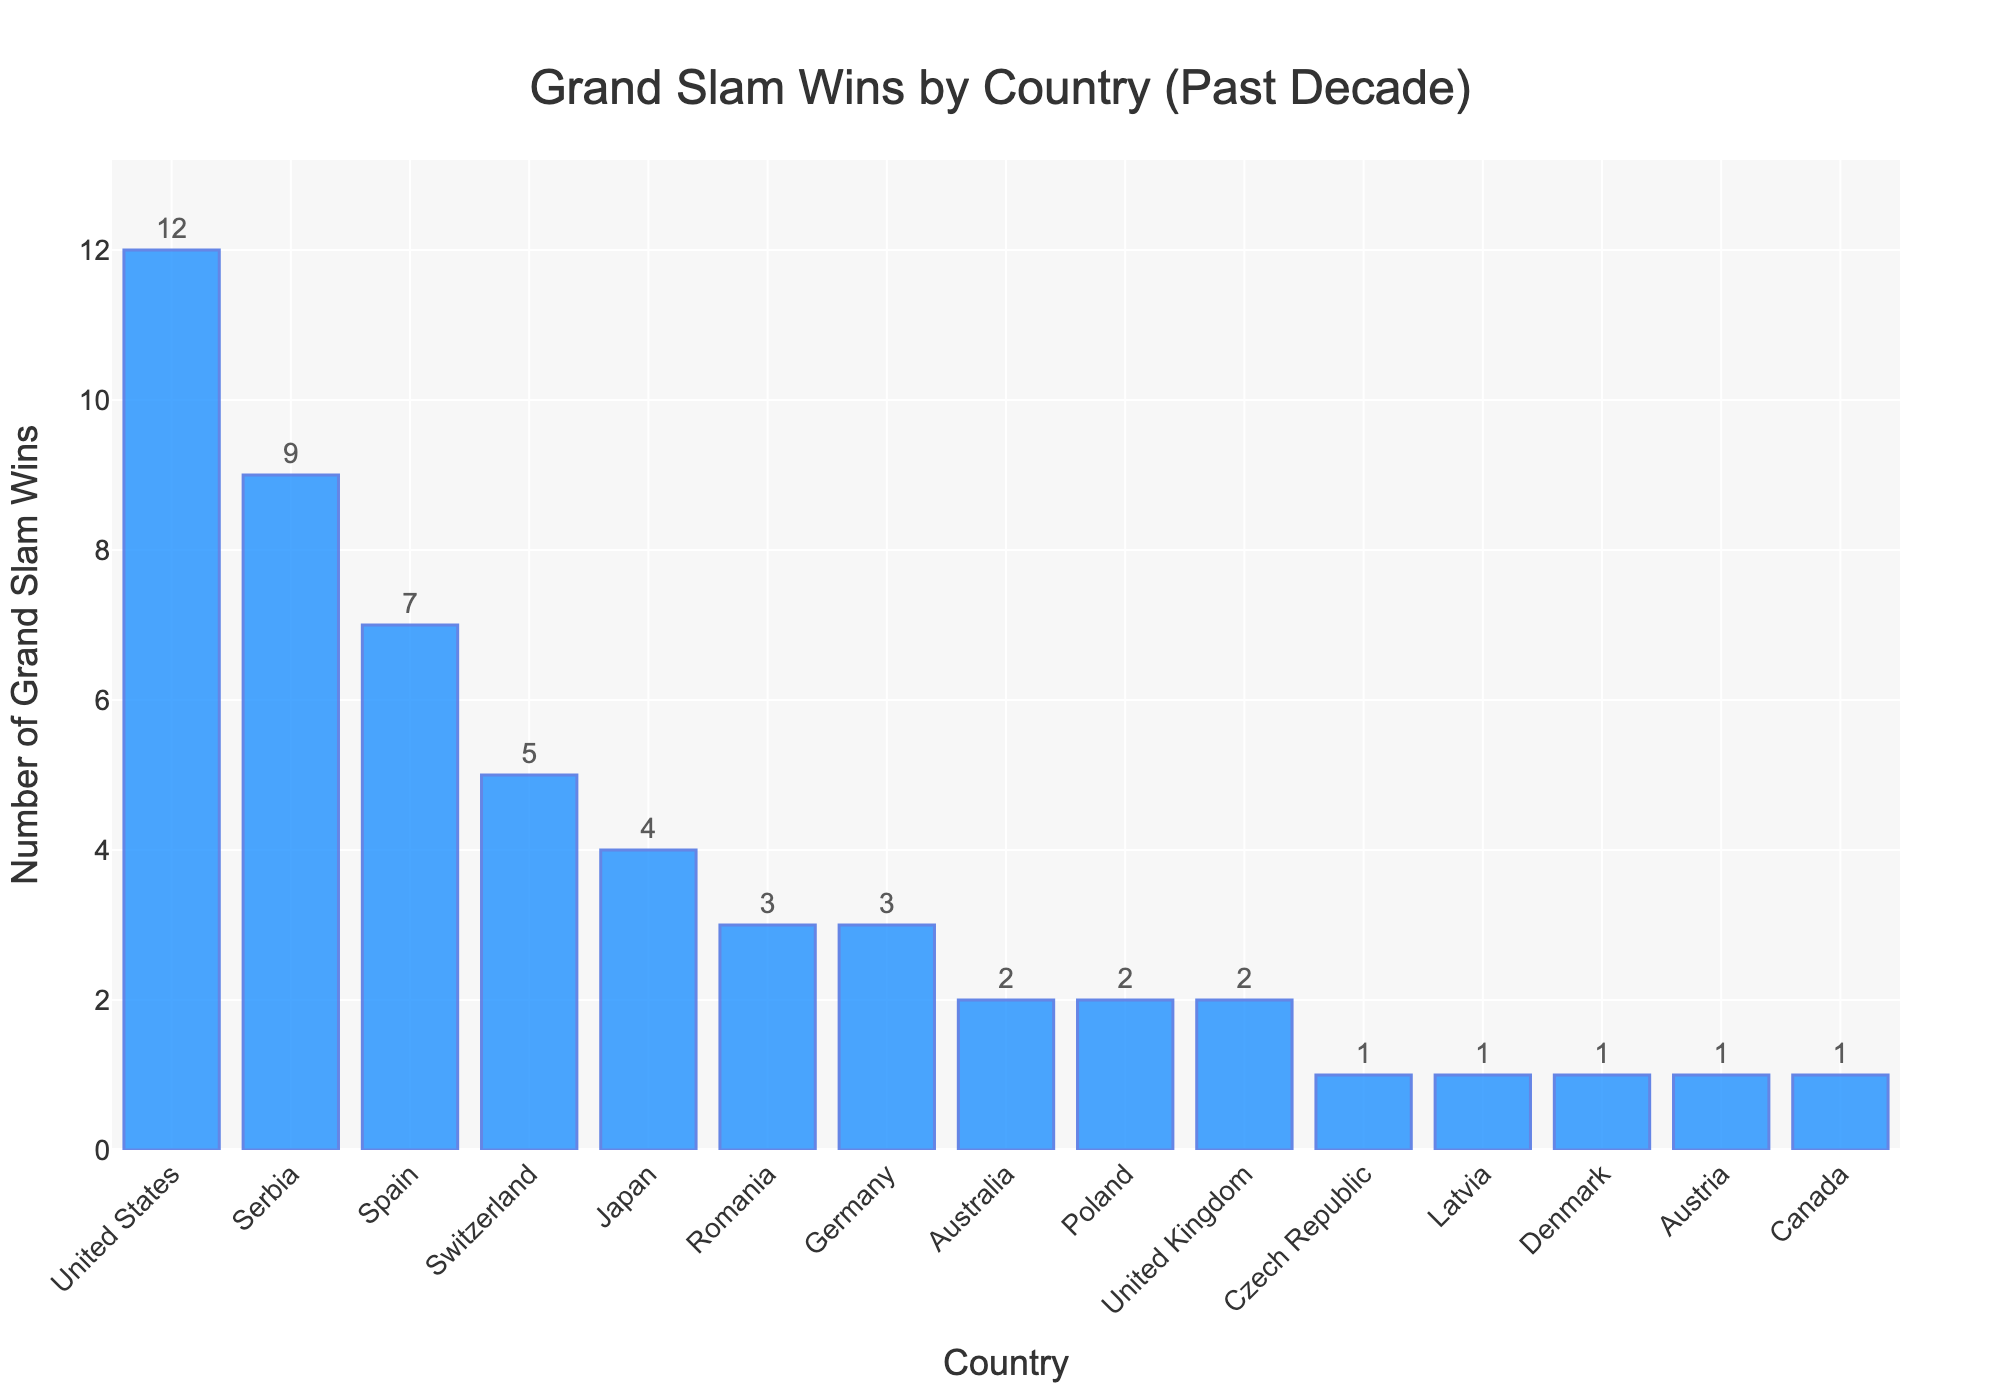Which country has the most Grand Slam wins? The tallest bar in the chart corresponds to the country with the most wins, which is the United States.
Answer: United States Which three countries have the lowest number of Grand Slam wins? The three shortest bars in the chart represent the countries with the lowest wins, which are Czech Republic, Latvia, Denmark, Austria, and Canada, all with 1 win each.
Answer: Czech Republic, Latvia, Denmark, Austria, Canada How many more Grand Slam wins does the United States have compared to Serbia? The bar for the United States shows 12 wins, and the bar for Serbia shows 9 wins. The difference is 12 - 9 = 3.
Answer: 3 What's the total number of Grand Slam wins by European countries? Adding the wins from the European countries: Serbia (9), Spain (7), Switzerland (5), Romania (3), Germany (3), Poland (2), United Kingdom (2), Czech Republic (1), Latvia (1), Denmark (1), Austria (1). The total is 9 + 7 + 5 + 3 + 3 + 2 + 2 + 1 + 1 + 1 + 1 = 35.
Answer: 35 Is the number of Grand Slam wins by Japan greater than or equal to the number of wins by Australia and Poland combined? Japan has 4 wins, while Australia and Poland each have 2 wins, making the combined total 4 (2+2). The number of wins by Japan (4) is equal to the combined total.
Answer: Equal How many countries have won more than 3 Grand Slam titles in the past decade? Counting the bars with heights representing more than 3 wins: United States (12), Serbia (9), Spain (7), Switzerland (5), and Japan (4). There are 5 such countries.
Answer: 5 What is the difference in Grand Slam wins between the country with the highest wins and the country with the lowest wins? The United States with the highest wins has 12, while the countries with the lowest wins (Czech Republic, Latvia, Denmark, Austria, Canada) each have 1. The difference is 12 - 1 = 11.
Answer: 11 What is the average number of Grand Slam wins for the top four countries? The top four countries are United States (12), Serbia (9), Spain (7), and Switzerland (5). The sum is 12 + 9 + 7 + 5 = 33, and the average is 33 / 4 = 8.25.
Answer: 8.25 Which countries have exactly 2 Grand Slam wins? The bars for Australia, Poland, and United Kingdom each show 2 wins.
Answer: Australia, Poland, United Kingdom 